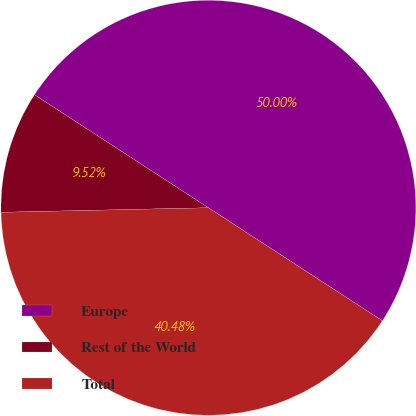<chart> <loc_0><loc_0><loc_500><loc_500><pie_chart><fcel>Europe<fcel>Rest of the World<fcel>Total<nl><fcel>50.0%<fcel>9.52%<fcel>40.48%<nl></chart> 